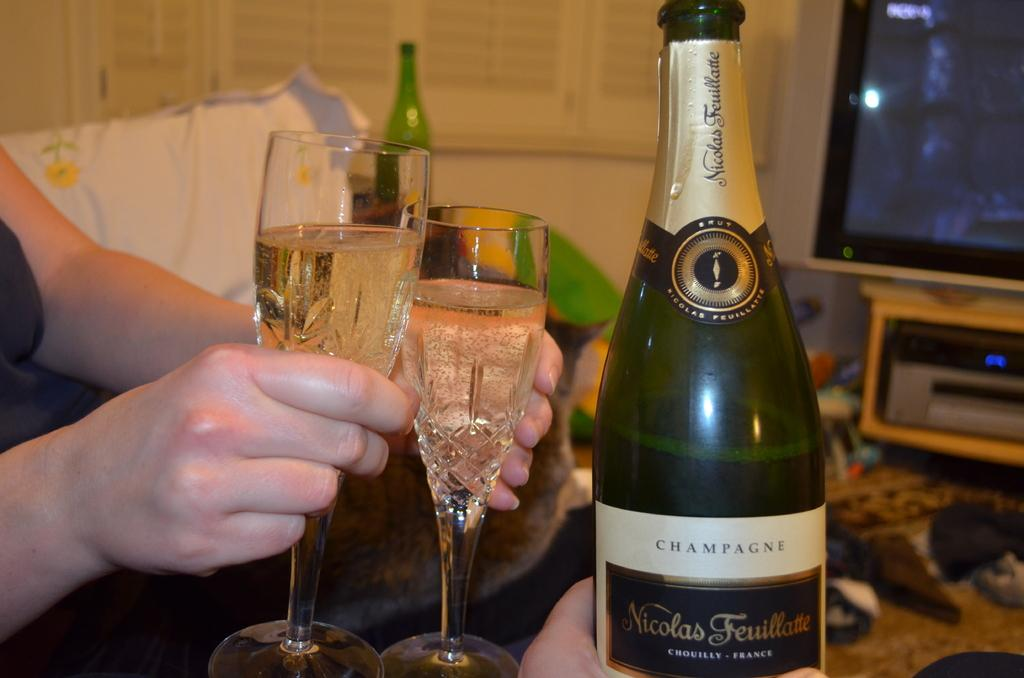<image>
Provide a brief description of the given image. person holds two flutes of Nicholas Feuillatte champagne 